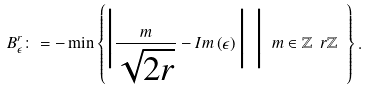<formula> <loc_0><loc_0><loc_500><loc_500>B _ { \epsilon } ^ { r } \colon = - \min \left \{ \Big | \frac { m } { \sqrt { 2 r } } - I m \left ( \epsilon \right ) \Big | \ \Big | \ m \in \mathbb { Z } \ r \mathbb { Z } \ \right \} .</formula> 